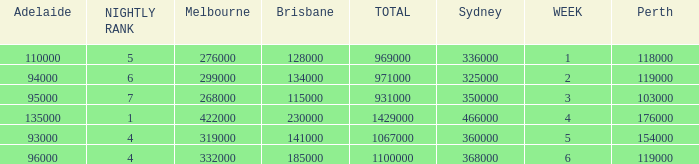What was the rating in Brisbane the week it was 276000 in Melbourne?  128000.0. 